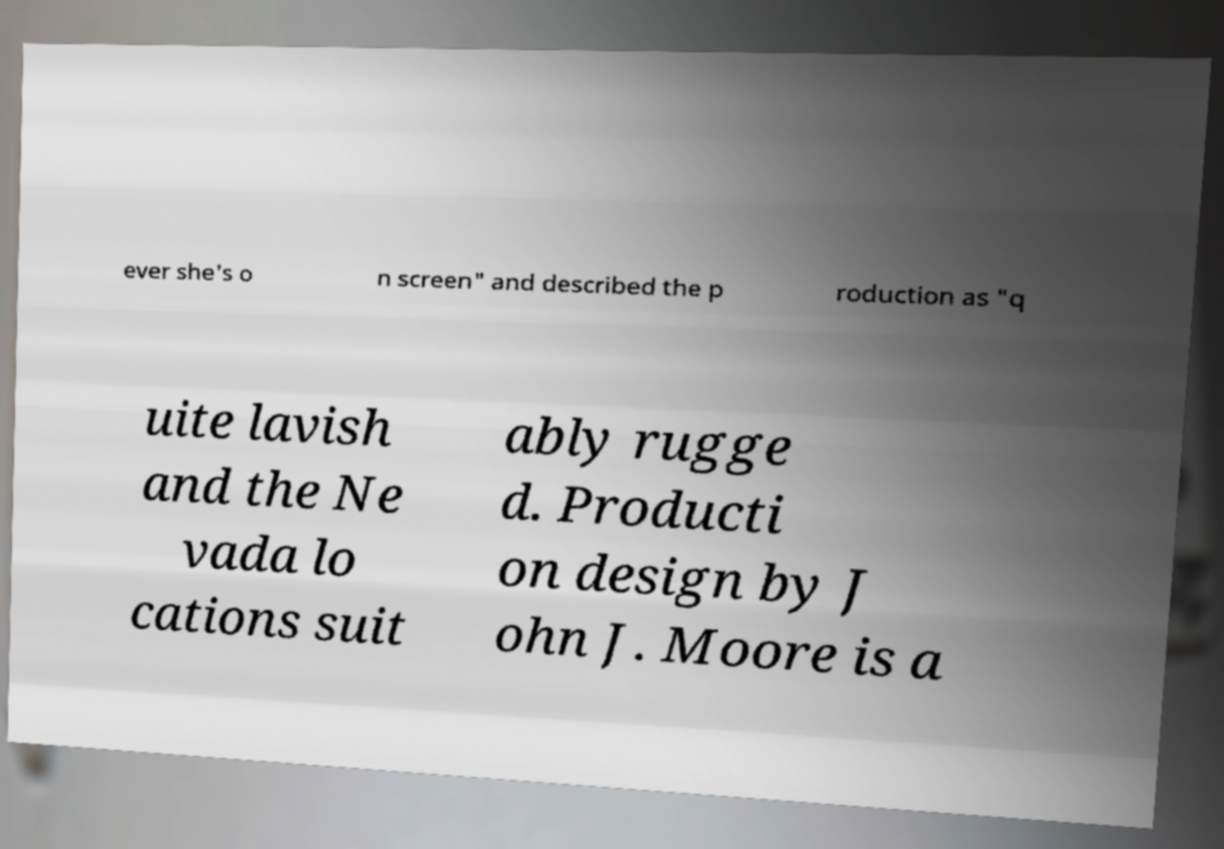Please identify and transcribe the text found in this image. ever she's o n screen" and described the p roduction as "q uite lavish and the Ne vada lo cations suit ably rugge d. Producti on design by J ohn J. Moore is a 